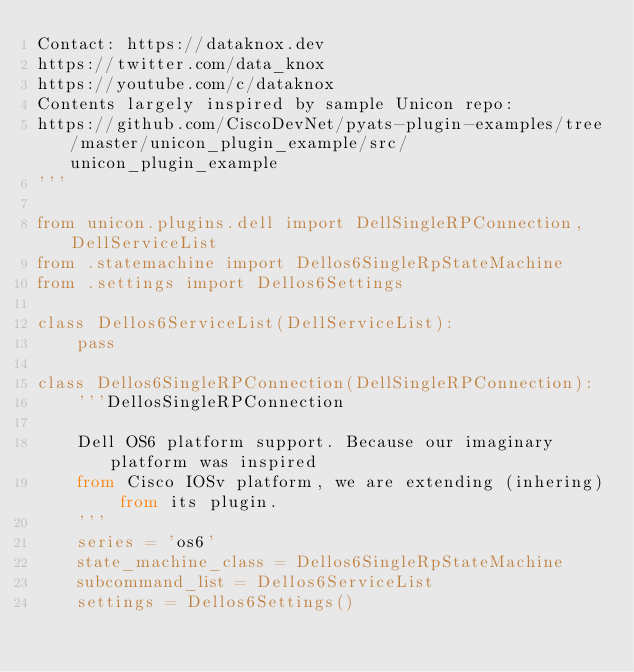Convert code to text. <code><loc_0><loc_0><loc_500><loc_500><_Python_>Contact: https://dataknox.dev
https://twitter.com/data_knox
https://youtube.com/c/dataknox
Contents largely inspired by sample Unicon repo:
https://github.com/CiscoDevNet/pyats-plugin-examples/tree/master/unicon_plugin_example/src/unicon_plugin_example
'''

from unicon.plugins.dell import DellSingleRPConnection, DellServiceList
from .statemachine import Dellos6SingleRpStateMachine
from .settings import Dellos6Settings

class Dellos6ServiceList(DellServiceList):
    pass

class Dellos6SingleRPConnection(DellSingleRPConnection):
    '''DellosSingleRPConnection

    Dell OS6 platform support. Because our imaginary platform was inspired
    from Cisco IOSv platform, we are extending (inhering) from its plugin.
    '''    
    series = 'os6'
    state_machine_class = Dellos6SingleRpStateMachine
    subcommand_list = Dellos6ServiceList
    settings = Dellos6Settings()
</code> 